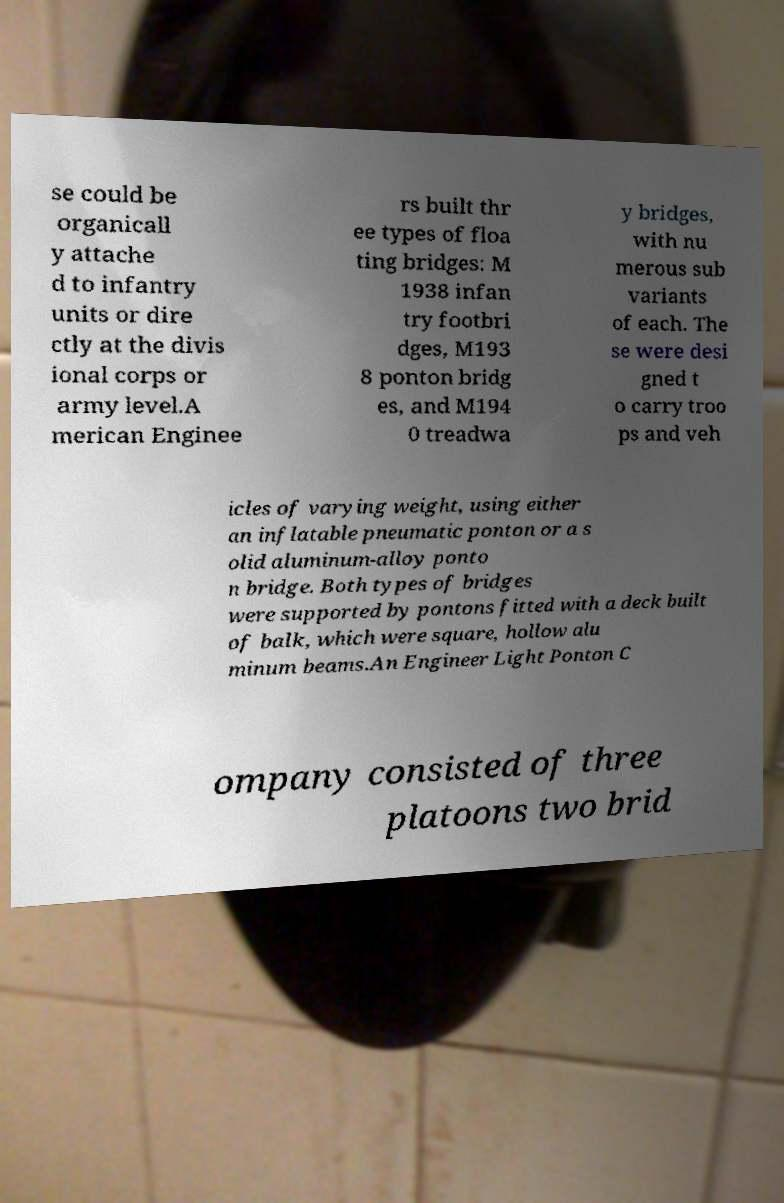I need the written content from this picture converted into text. Can you do that? se could be organicall y attache d to infantry units or dire ctly at the divis ional corps or army level.A merican Enginee rs built thr ee types of floa ting bridges: M 1938 infan try footbri dges, M193 8 ponton bridg es, and M194 0 treadwa y bridges, with nu merous sub variants of each. The se were desi gned t o carry troo ps and veh icles of varying weight, using either an inflatable pneumatic ponton or a s olid aluminum-alloy ponto n bridge. Both types of bridges were supported by pontons fitted with a deck built of balk, which were square, hollow alu minum beams.An Engineer Light Ponton C ompany consisted of three platoons two brid 